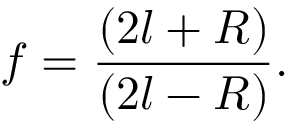<formula> <loc_0><loc_0><loc_500><loc_500>f = \frac { ( 2 l + R ) } { ( 2 l - R ) } .</formula> 